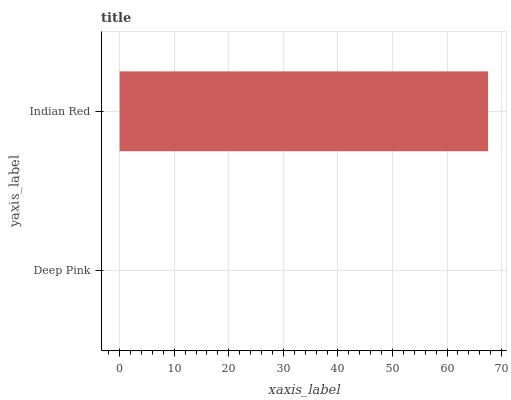Is Deep Pink the minimum?
Answer yes or no. Yes. Is Indian Red the maximum?
Answer yes or no. Yes. Is Indian Red the minimum?
Answer yes or no. No. Is Indian Red greater than Deep Pink?
Answer yes or no. Yes. Is Deep Pink less than Indian Red?
Answer yes or no. Yes. Is Deep Pink greater than Indian Red?
Answer yes or no. No. Is Indian Red less than Deep Pink?
Answer yes or no. No. Is Indian Red the high median?
Answer yes or no. Yes. Is Deep Pink the low median?
Answer yes or no. Yes. Is Deep Pink the high median?
Answer yes or no. No. Is Indian Red the low median?
Answer yes or no. No. 